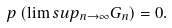<formula> <loc_0><loc_0><loc_500><loc_500>\ p \left ( \lim s u p _ { n \to \infty } G _ { n } \right ) = 0 .</formula> 